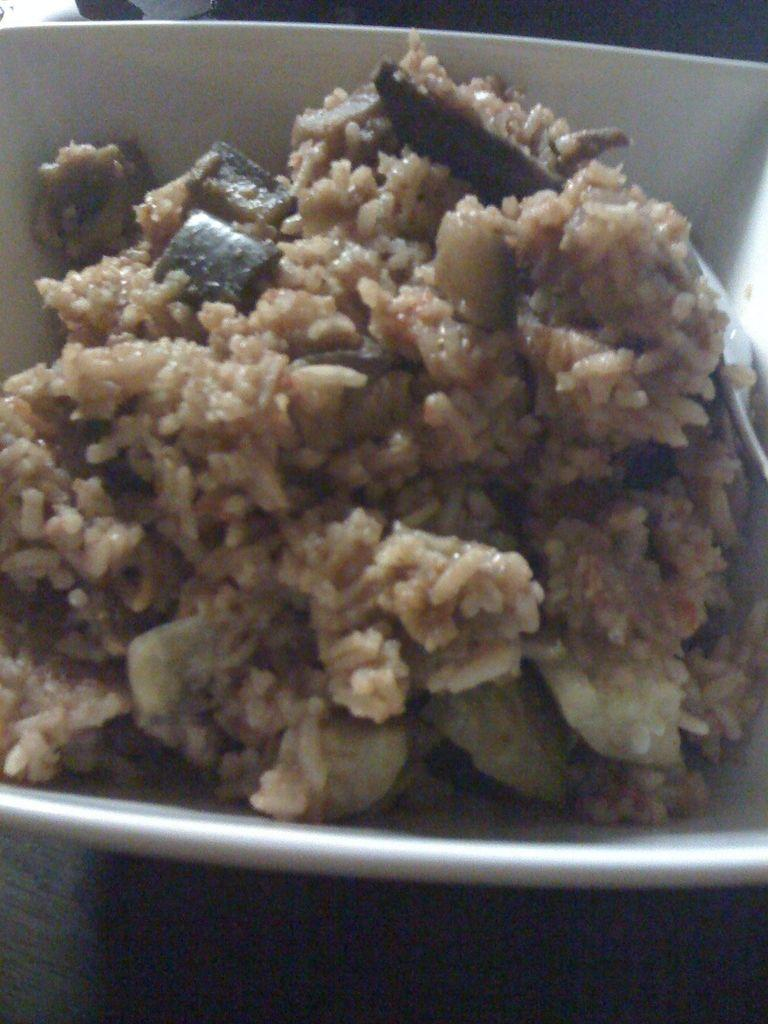What is the main subject of the image? The main subject of the image is food. What color is the food in the image? The food is in brown color. What color is the bowl containing the food? The bowl is in white color. What type of territory can be seen in the image? There is no territory visible in the image; it features food in a bowl. How many crows are present in the image? There are no crows present in the image. 